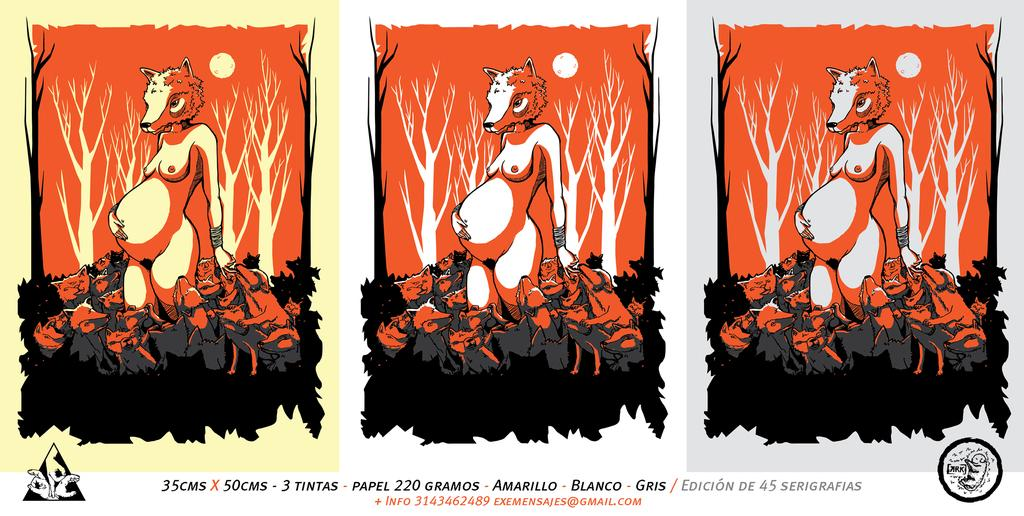<image>
Create a compact narrative representing the image presented. A cartoon titled 3 tintas with three different background colors. 